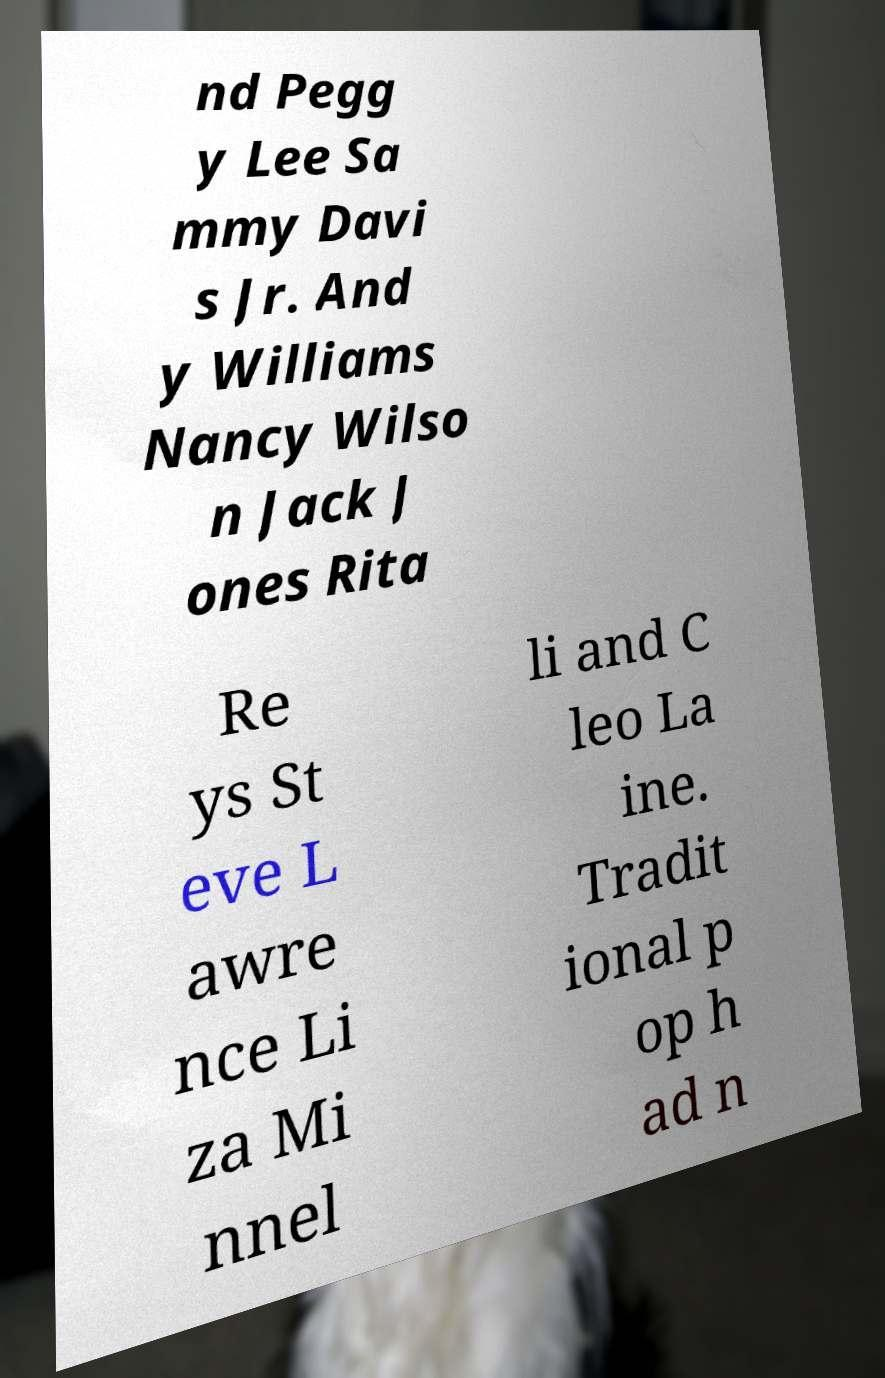Please identify and transcribe the text found in this image. nd Pegg y Lee Sa mmy Davi s Jr. And y Williams Nancy Wilso n Jack J ones Rita Re ys St eve L awre nce Li za Mi nnel li and C leo La ine. Tradit ional p op h ad n 